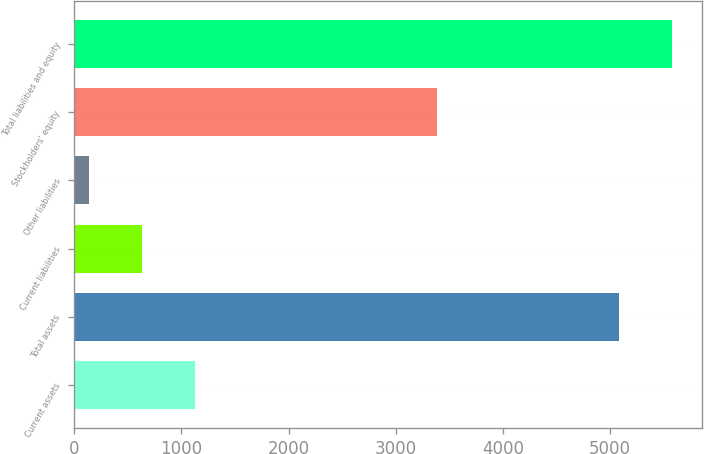Convert chart to OTSL. <chart><loc_0><loc_0><loc_500><loc_500><bar_chart><fcel>Current assets<fcel>Total assets<fcel>Current liabilities<fcel>Other liabilities<fcel>Stockholders' equity<fcel>Total liabilities and equity<nl><fcel>1130.6<fcel>5086.6<fcel>636.1<fcel>141.6<fcel>3382.9<fcel>5581.1<nl></chart> 